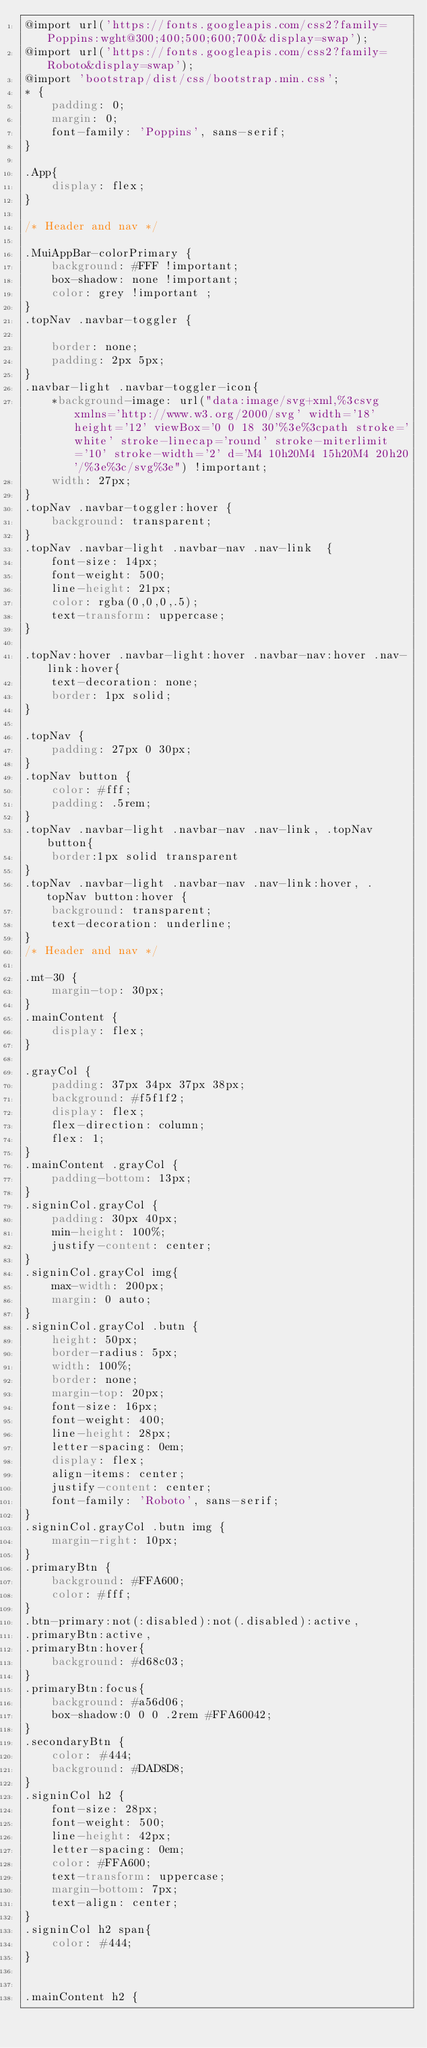Convert code to text. <code><loc_0><loc_0><loc_500><loc_500><_CSS_>@import url('https://fonts.googleapis.com/css2?family=Poppins:wght@300;400;500;600;700&display=swap');
@import url('https://fonts.googleapis.com/css2?family=Roboto&display=swap');
@import 'bootstrap/dist/css/bootstrap.min.css';
* {
    padding: 0;
    margin: 0;
    font-family: 'Poppins', sans-serif;
}

.App{
    display: flex;
}

/* Header and nav */

.MuiAppBar-colorPrimary {
    background: #FFF !important;
    box-shadow: none !important;
    color: grey !important ;
}
.topNav .navbar-toggler {

    border: none;
    padding: 2px 5px;
}
.navbar-light .navbar-toggler-icon{
    *background-image: url("data:image/svg+xml,%3csvg xmlns='http://www.w3.org/2000/svg' width='18' height='12' viewBox='0 0 18 30'%3e%3cpath stroke='white' stroke-linecap='round' stroke-miterlimit='10' stroke-width='2' d='M4 10h20M4 15h20M4 20h20'/%3e%3c/svg%3e") !important;
    width: 27px;
}
.topNav .navbar-toggler:hover {
    background: transparent;
}
.topNav .navbar-light .navbar-nav .nav-link  {
    font-size: 14px;
    font-weight: 500;
    line-height: 21px;
    color: rgba(0,0,0,.5);
    text-transform: uppercase;
}

.topNav:hover .navbar-light:hover .navbar-nav:hover .nav-link:hover{
    text-decoration: none;
    border: 1px solid;
}

.topNav {
    padding: 27px 0 30px;
}
.topNav button {
    color: #fff;
    padding: .5rem;
}
.topNav .navbar-light .navbar-nav .nav-link, .topNav button{
    border:1px solid transparent
}
.topNav .navbar-light .navbar-nav .nav-link:hover, .topNav button:hover {
    background: transparent;
    text-decoration: underline;
}
/* Header and nav */

.mt-30 {
    margin-top: 30px;
}
.mainContent {
    display: flex;
}

.grayCol {
    padding: 37px 34px 37px 38px;
    background: #f5f1f2;
    display: flex;
    flex-direction: column;
    flex: 1;
}
.mainContent .grayCol {
    padding-bottom: 13px;
}
.signinCol.grayCol {
    padding: 30px 40px;
    min-height: 100%;
    justify-content: center;
}
.signinCol.grayCol img{
    max-width: 200px;
    margin: 0 auto;
}
.signinCol.grayCol .butn {
    height: 50px;
    border-radius: 5px;
    width: 100%;
    border: none;
    margin-top: 20px;
    font-size: 16px;
    font-weight: 400;
    line-height: 28px;
    letter-spacing: 0em;
    display: flex;
    align-items: center;
    justify-content: center;
    font-family: 'Roboto', sans-serif;
}
.signinCol.grayCol .butn img {
    margin-right: 10px;
}
.primaryBtn {
    background: #FFA600;
    color: #fff;
}
.btn-primary:not(:disabled):not(.disabled):active,
.primaryBtn:active,
.primaryBtn:hover{
    background: #d68c03;
}
.primaryBtn:focus{
    background: #a56d06;
    box-shadow:0 0 0 .2rem #FFA60042;
}
.secondaryBtn {
    color: #444;
    background: #DAD8D8;
}
.signinCol h2 {
    font-size: 28px;
    font-weight: 500;
    line-height: 42px;
    letter-spacing: 0em;
    color: #FFA600;
    text-transform: uppercase;
    margin-bottom: 7px;
    text-align: center;
}
.signinCol h2 span{
    color: #444;
}


.mainContent h2 {</code> 